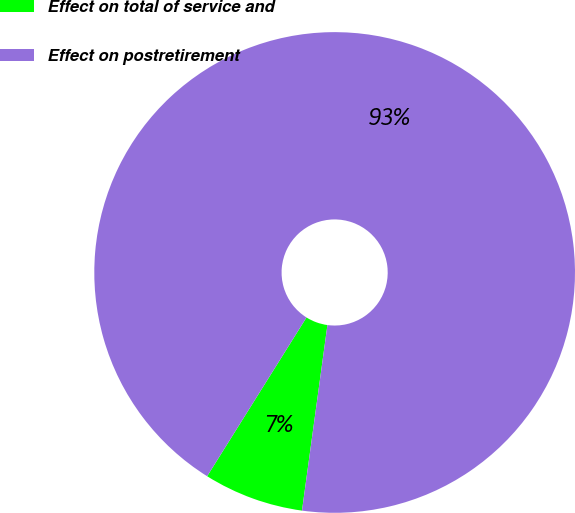<chart> <loc_0><loc_0><loc_500><loc_500><pie_chart><fcel>Effect on total of service and<fcel>Effect on postretirement<nl><fcel>6.73%<fcel>93.27%<nl></chart> 